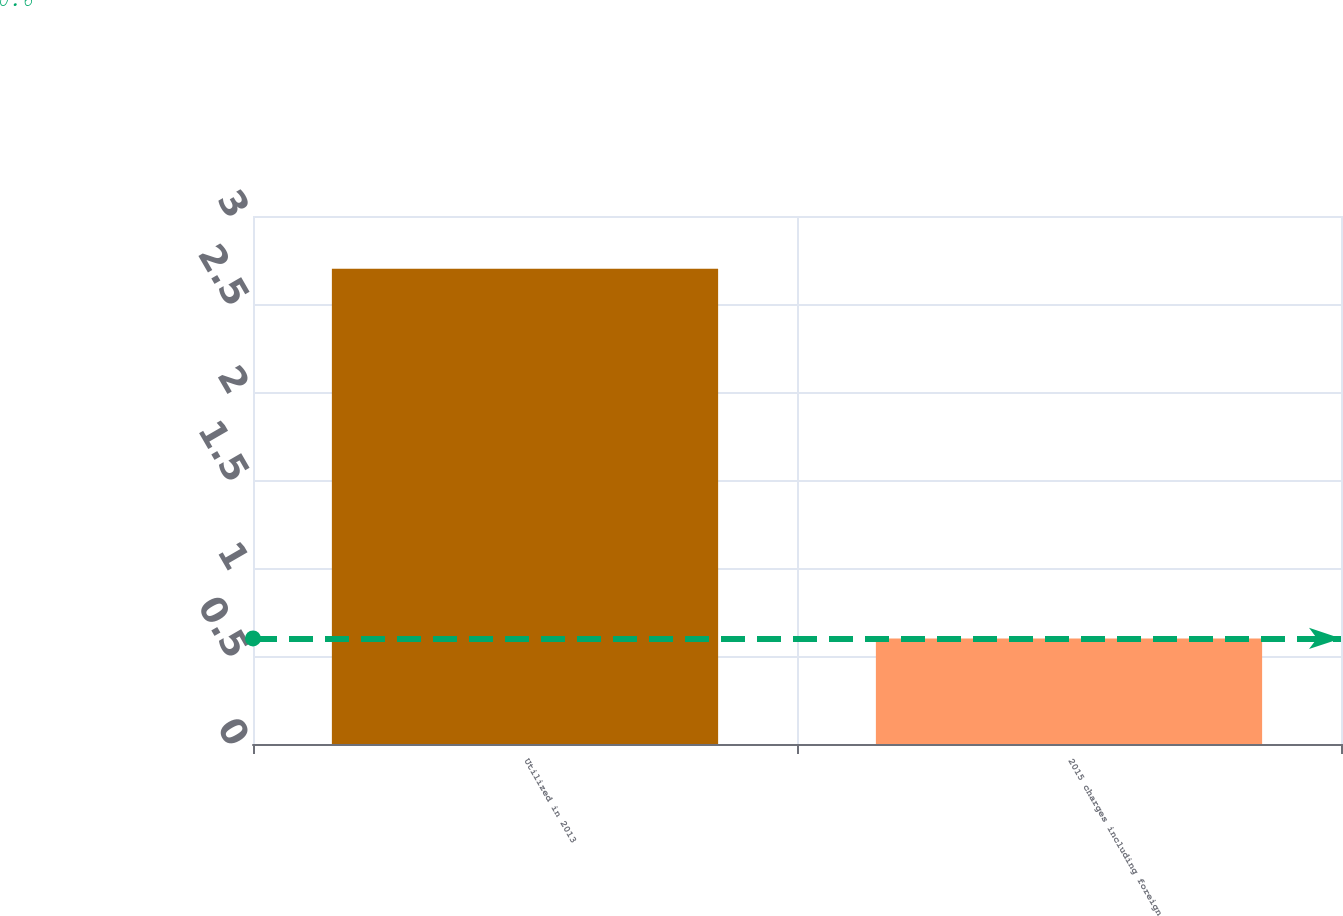<chart> <loc_0><loc_0><loc_500><loc_500><bar_chart><fcel>Utilized in 2013<fcel>2015 charges including foreign<nl><fcel>2.7<fcel>0.6<nl></chart> 